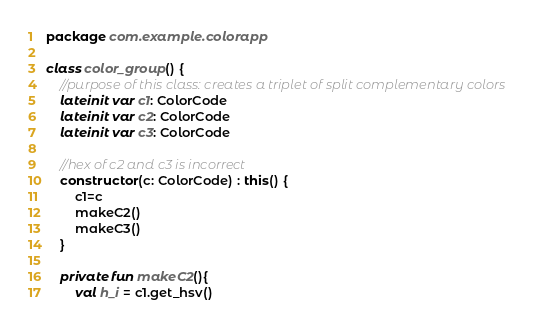<code> <loc_0><loc_0><loc_500><loc_500><_Kotlin_>package com.example.colorapp

class color_group() {
    //purpose of this class: creates a triplet of split complementary colors
    lateinit var c1: ColorCode
    lateinit var c2: ColorCode
    lateinit var c3: ColorCode

    //hex of c2 and c3 is incorrect
    constructor(c: ColorCode) : this() {
        c1=c
        makeC2()
        makeC3()
    }

    private fun makeC2(){
        val h_i = c1.get_hsv()</code> 